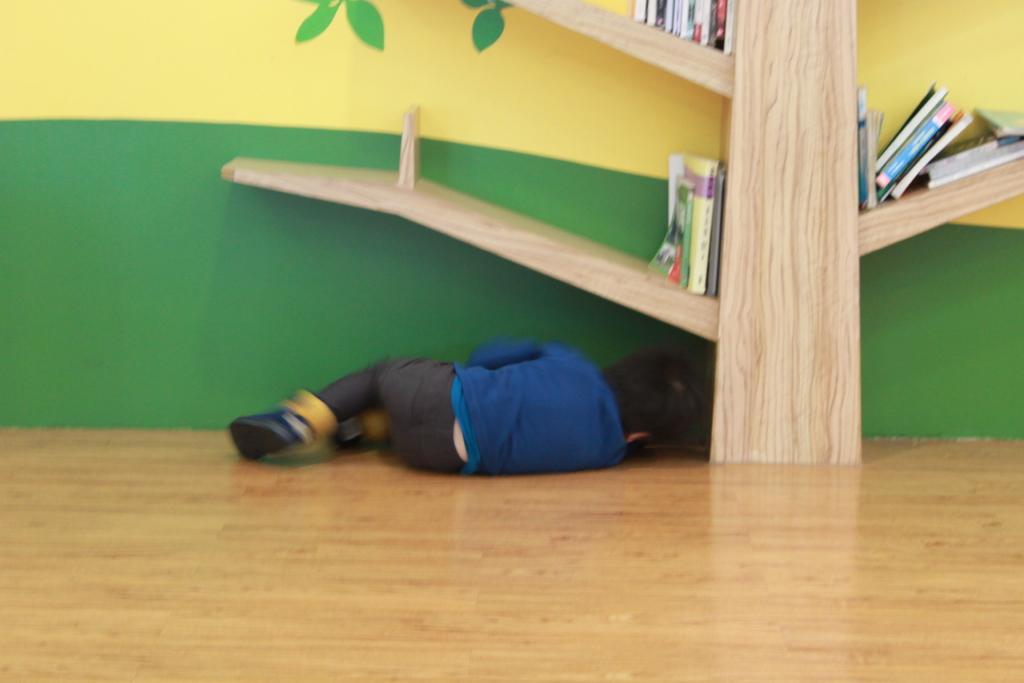In one or two sentences, can you explain what this image depicts? This picture is clicked inside. In the foreground we can see the floor and there is a kid wearing blue color dress and seems to be lying on the floor. In the center we can see the shelf containing books. In the background there is a wall. 